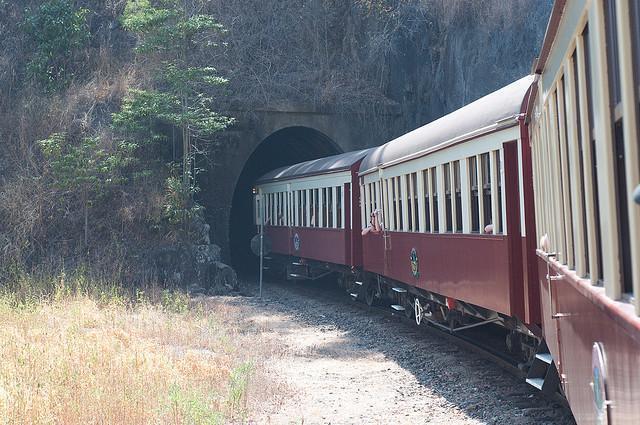If the train continues forward what will make it go out of sight first?
Pick the correct solution from the four options below to address the question.
Options: Bridge, building, tunnel, extreme distance. Tunnel. 